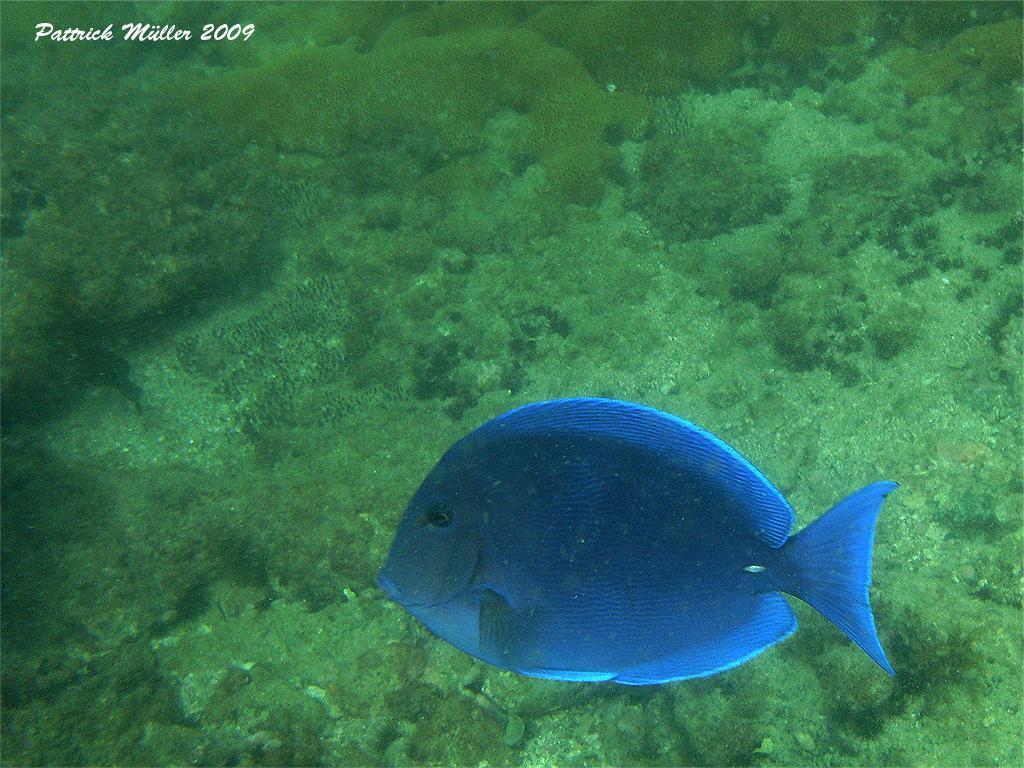Please provide a concise description of this image. In this image I can see a blue colour fish over here and in the background I can see green colour. I can also see watermark over here. 